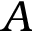<formula> <loc_0><loc_0><loc_500><loc_500>A</formula> 